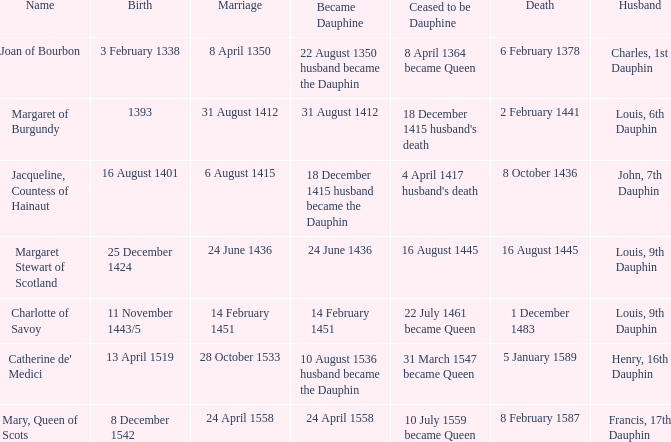When was the death when the birth was 8 december 1542? 8 February 1587. 